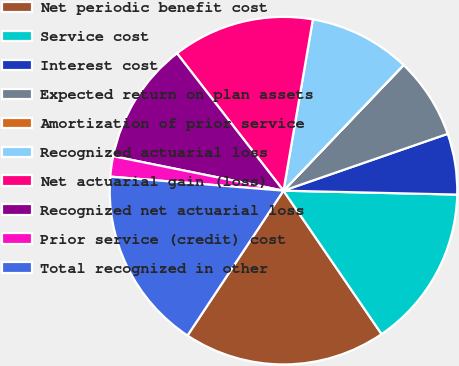Convert chart to OTSL. <chart><loc_0><loc_0><loc_500><loc_500><pie_chart><fcel>Net periodic benefit cost<fcel>Service cost<fcel>Interest cost<fcel>Expected return on plan assets<fcel>Amortization of prior service<fcel>Recognized actuarial loss<fcel>Net actuarial gain (loss)<fcel>Recognized net actuarial loss<fcel>Prior service (credit) cost<fcel>Total recognized in other<nl><fcel>18.86%<fcel>15.09%<fcel>5.66%<fcel>7.55%<fcel>0.01%<fcel>9.43%<fcel>13.2%<fcel>11.32%<fcel>1.89%<fcel>16.97%<nl></chart> 